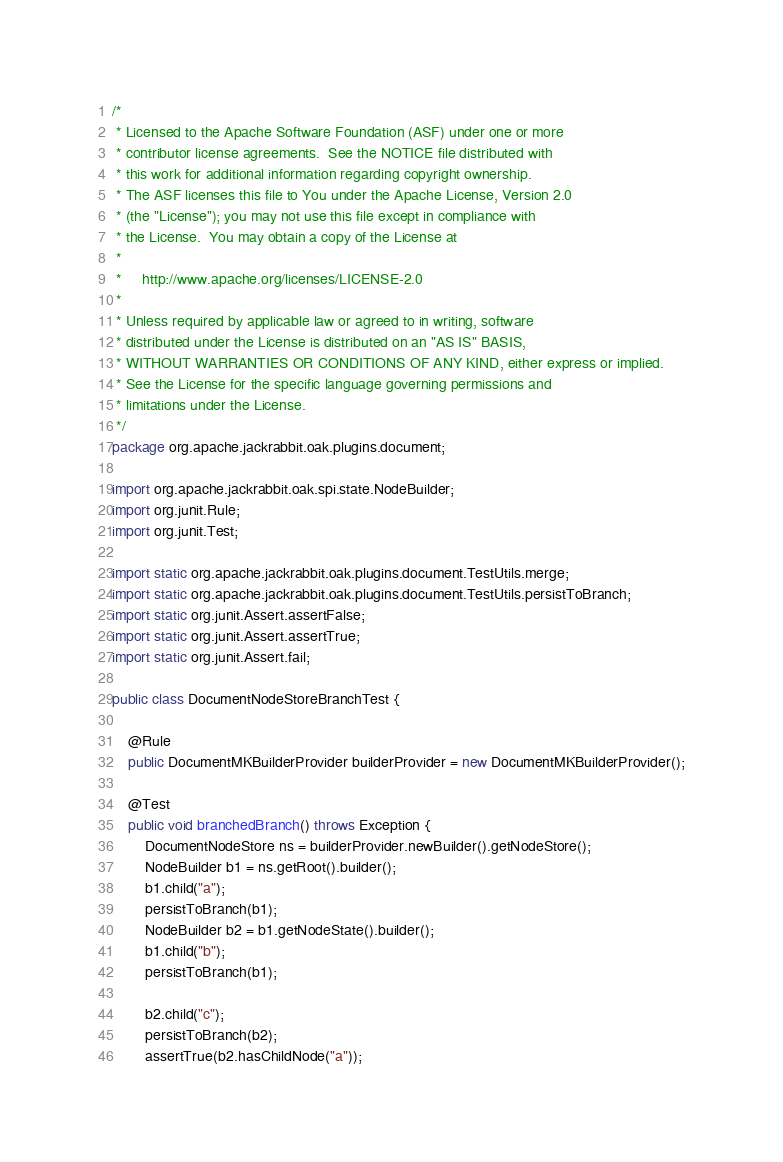<code> <loc_0><loc_0><loc_500><loc_500><_Java_>/*
 * Licensed to the Apache Software Foundation (ASF) under one or more
 * contributor license agreements.  See the NOTICE file distributed with
 * this work for additional information regarding copyright ownership.
 * The ASF licenses this file to You under the Apache License, Version 2.0
 * (the "License"); you may not use this file except in compliance with
 * the License.  You may obtain a copy of the License at
 *
 *     http://www.apache.org/licenses/LICENSE-2.0
 *
 * Unless required by applicable law or agreed to in writing, software
 * distributed under the License is distributed on an "AS IS" BASIS,
 * WITHOUT WARRANTIES OR CONDITIONS OF ANY KIND, either express or implied.
 * See the License for the specific language governing permissions and
 * limitations under the License.
 */
package org.apache.jackrabbit.oak.plugins.document;

import org.apache.jackrabbit.oak.spi.state.NodeBuilder;
import org.junit.Rule;
import org.junit.Test;

import static org.apache.jackrabbit.oak.plugins.document.TestUtils.merge;
import static org.apache.jackrabbit.oak.plugins.document.TestUtils.persistToBranch;
import static org.junit.Assert.assertFalse;
import static org.junit.Assert.assertTrue;
import static org.junit.Assert.fail;

public class DocumentNodeStoreBranchTest {

    @Rule
    public DocumentMKBuilderProvider builderProvider = new DocumentMKBuilderProvider();

    @Test
    public void branchedBranch() throws Exception {
        DocumentNodeStore ns = builderProvider.newBuilder().getNodeStore();
        NodeBuilder b1 = ns.getRoot().builder();
        b1.child("a");
        persistToBranch(b1);
        NodeBuilder b2 = b1.getNodeState().builder();
        b1.child("b");
        persistToBranch(b1);

        b2.child("c");
        persistToBranch(b2);
        assertTrue(b2.hasChildNode("a"));</code> 